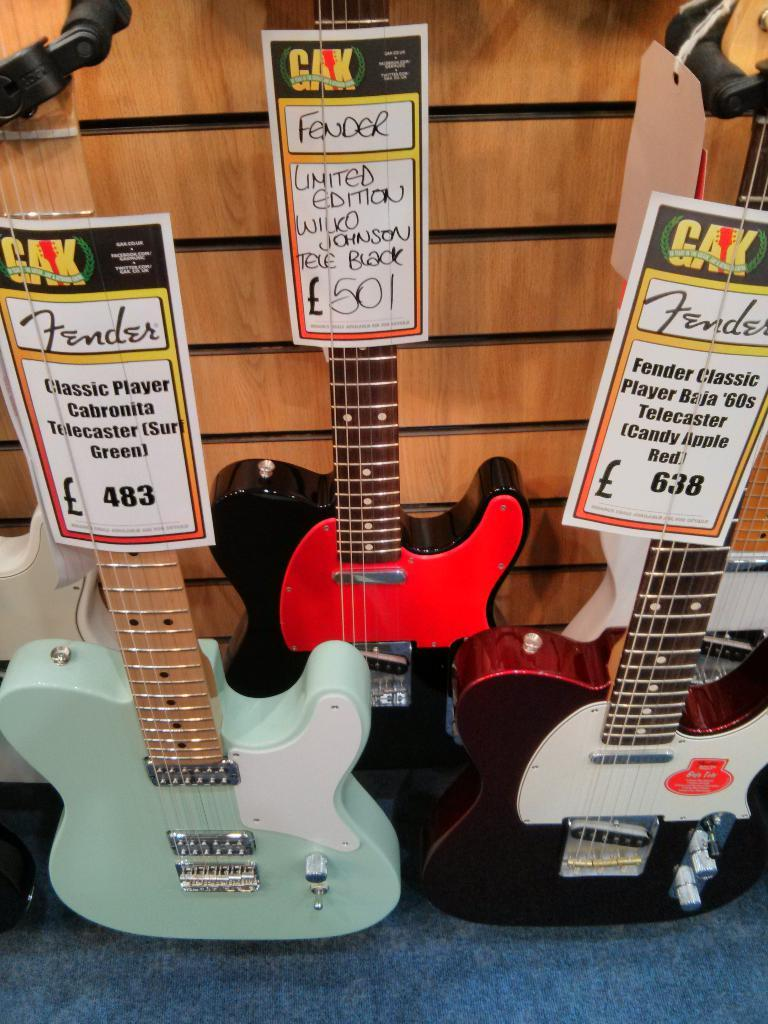What musical instruments are on the floor in the image? There are guitars on the floor. Where is the throne located in the image? There is no throne present in the image. What type of plants can be seen growing on the floor in the image? There are no plants visible on the floor in the image; only guitars are present. 